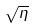<formula> <loc_0><loc_0><loc_500><loc_500>\sqrt { \eta }</formula> 